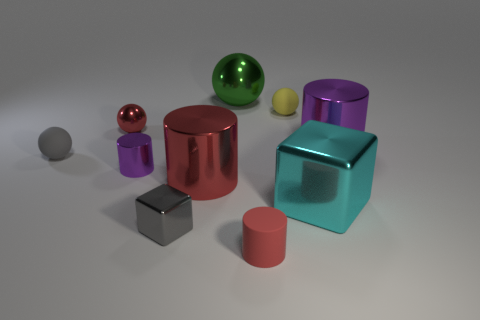Subtract all balls. How many objects are left? 6 Add 1 big brown rubber blocks. How many big brown rubber blocks exist? 1 Subtract 0 blue balls. How many objects are left? 10 Subtract all cyan metallic objects. Subtract all big gray matte cubes. How many objects are left? 9 Add 8 tiny red objects. How many tiny red objects are left? 10 